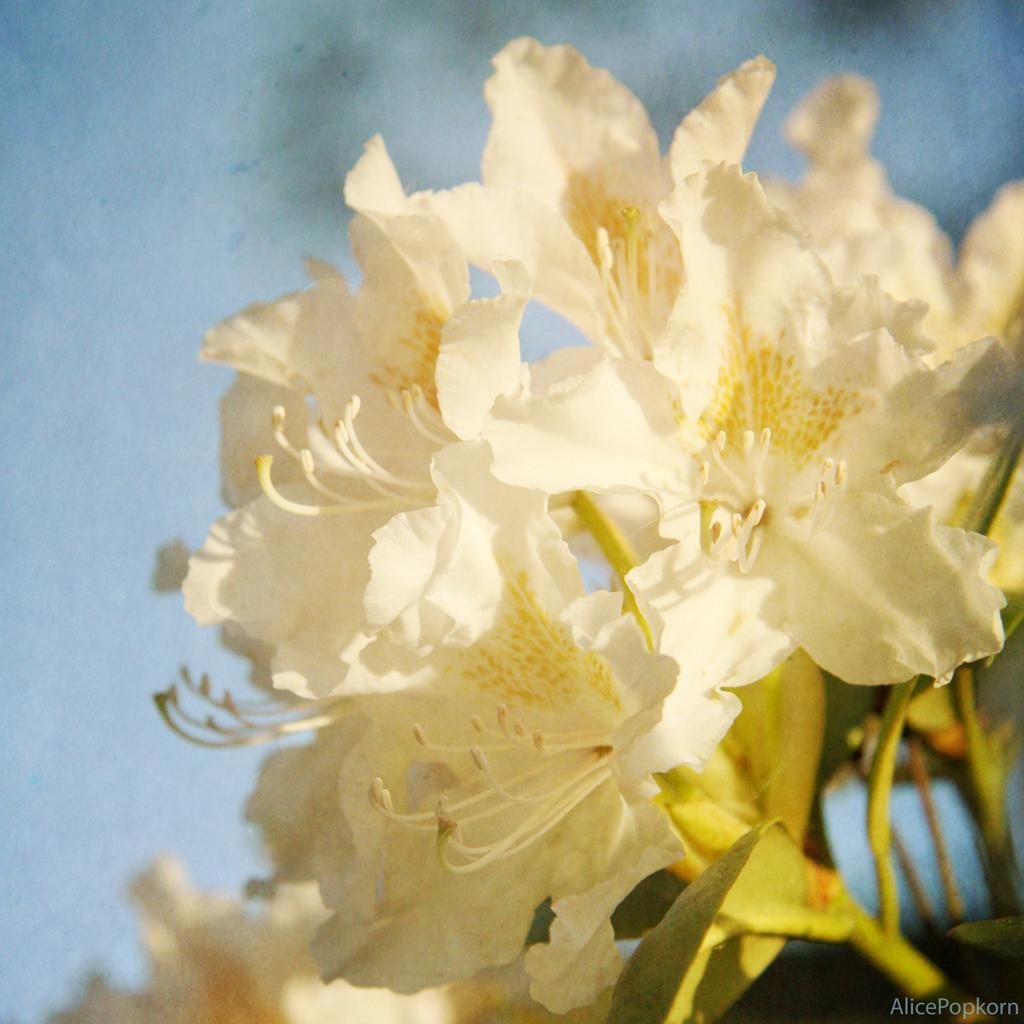What type of flowers are visible in the image? There are white flowers on stems in the image. Can you describe the background of the image? The background is blurred in the image. Where is the text or writing located in the image? The text or writing is in the right bottom corner of the image. How many fingers can be seen pointing at the flowers in the image? There are no fingers visible in the image, so it is not possible to determine the number of fingers pointing at the flowers. 